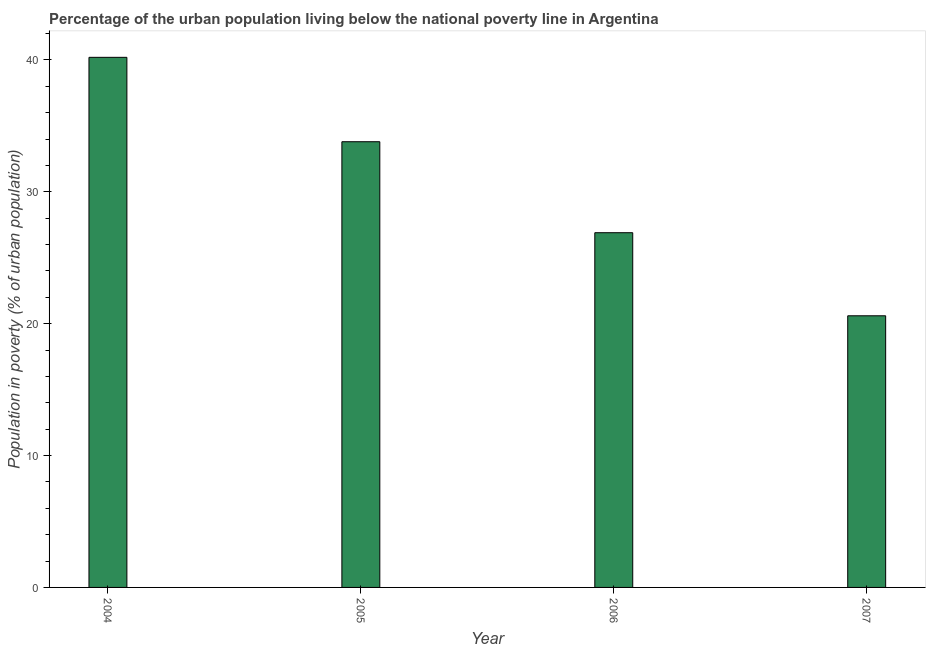Does the graph contain any zero values?
Offer a terse response. No. What is the title of the graph?
Make the answer very short. Percentage of the urban population living below the national poverty line in Argentina. What is the label or title of the X-axis?
Offer a terse response. Year. What is the label or title of the Y-axis?
Provide a short and direct response. Population in poverty (% of urban population). What is the percentage of urban population living below poverty line in 2005?
Ensure brevity in your answer.  33.8. Across all years, what is the maximum percentage of urban population living below poverty line?
Offer a terse response. 40.2. Across all years, what is the minimum percentage of urban population living below poverty line?
Provide a succinct answer. 20.6. In which year was the percentage of urban population living below poverty line maximum?
Your answer should be very brief. 2004. In which year was the percentage of urban population living below poverty line minimum?
Provide a short and direct response. 2007. What is the sum of the percentage of urban population living below poverty line?
Offer a very short reply. 121.5. What is the average percentage of urban population living below poverty line per year?
Offer a terse response. 30.38. What is the median percentage of urban population living below poverty line?
Your answer should be compact. 30.35. What is the ratio of the percentage of urban population living below poverty line in 2004 to that in 2005?
Make the answer very short. 1.19. What is the difference between the highest and the lowest percentage of urban population living below poverty line?
Provide a short and direct response. 19.6. In how many years, is the percentage of urban population living below poverty line greater than the average percentage of urban population living below poverty line taken over all years?
Give a very brief answer. 2. How many bars are there?
Keep it short and to the point. 4. What is the difference between two consecutive major ticks on the Y-axis?
Make the answer very short. 10. What is the Population in poverty (% of urban population) of 2004?
Keep it short and to the point. 40.2. What is the Population in poverty (% of urban population) of 2005?
Your response must be concise. 33.8. What is the Population in poverty (% of urban population) of 2006?
Your answer should be very brief. 26.9. What is the Population in poverty (% of urban population) of 2007?
Provide a short and direct response. 20.6. What is the difference between the Population in poverty (% of urban population) in 2004 and 2006?
Make the answer very short. 13.3. What is the difference between the Population in poverty (% of urban population) in 2004 and 2007?
Provide a succinct answer. 19.6. What is the difference between the Population in poverty (% of urban population) in 2005 and 2007?
Offer a very short reply. 13.2. What is the ratio of the Population in poverty (% of urban population) in 2004 to that in 2005?
Provide a succinct answer. 1.19. What is the ratio of the Population in poverty (% of urban population) in 2004 to that in 2006?
Offer a very short reply. 1.49. What is the ratio of the Population in poverty (% of urban population) in 2004 to that in 2007?
Your answer should be very brief. 1.95. What is the ratio of the Population in poverty (% of urban population) in 2005 to that in 2006?
Make the answer very short. 1.26. What is the ratio of the Population in poverty (% of urban population) in 2005 to that in 2007?
Provide a short and direct response. 1.64. What is the ratio of the Population in poverty (% of urban population) in 2006 to that in 2007?
Your response must be concise. 1.31. 